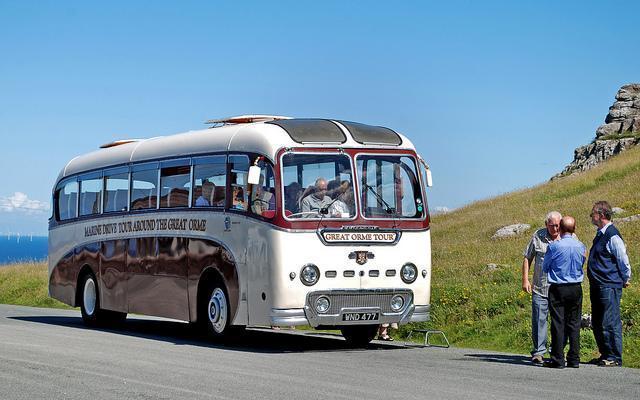How many people are outside of the vehicle?
Give a very brief answer. 3. How many people are visible?
Give a very brief answer. 3. How many ski poles is the person holding?
Give a very brief answer. 0. 